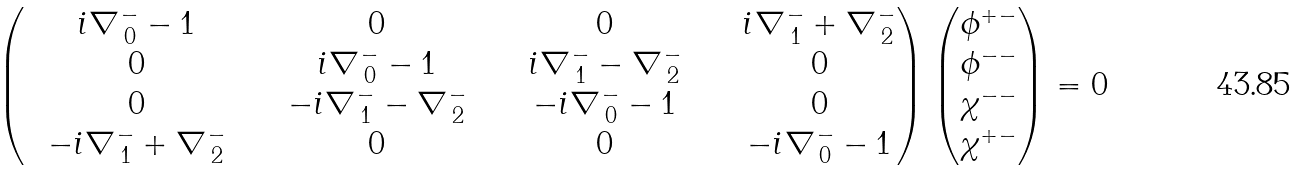Convert formula to latex. <formula><loc_0><loc_0><loc_500><loc_500>\, \begin{pmatrix} \ \ i \nabla ^ { - } _ { \, 0 } - 1 \ \ & \ \ 0 \ \ & \ \ 0 \ \ & \ \ i \nabla ^ { - } _ { \, 1 } + \nabla ^ { - } _ { \, 2 } \\ \ \ 0 \ \ & \ \ i \nabla ^ { - } _ { \, 0 } - 1 \ \ & \ \ i \nabla ^ { - } _ { \, 1 } - \nabla ^ { - } _ { \, 2 } \ \ & \ \ 0 \\ \ \ 0 \ \ & \ \ - i \nabla ^ { - } _ { \, 1 } - \nabla ^ { - } _ { \, 2 } \ \ & \ \ - i \nabla ^ { - } _ { \, 0 } - 1 \ \ & \ \ 0 \\ \ \ - i \nabla ^ { - } _ { \, 1 } + \nabla ^ { - } _ { \, 2 } \ \ & \ \ 0 \ \ & \ \ 0 \ \ & \ \ - i \nabla ^ { - } _ { \, 0 } - 1 \end{pmatrix} \begin{pmatrix} \phi ^ { + - } \\ \phi ^ { - - } \\ \chi ^ { - - } \\ \chi ^ { + - } \end{pmatrix} = 0</formula> 